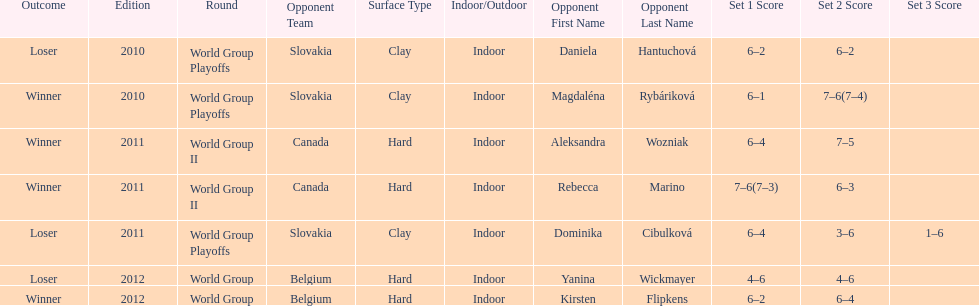What was the next game listed after the world group ii rounds? World Group Playoffs. 